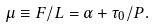Convert formula to latex. <formula><loc_0><loc_0><loc_500><loc_500>\mu \equiv F / L = \alpha + \tau _ { 0 } / P .</formula> 